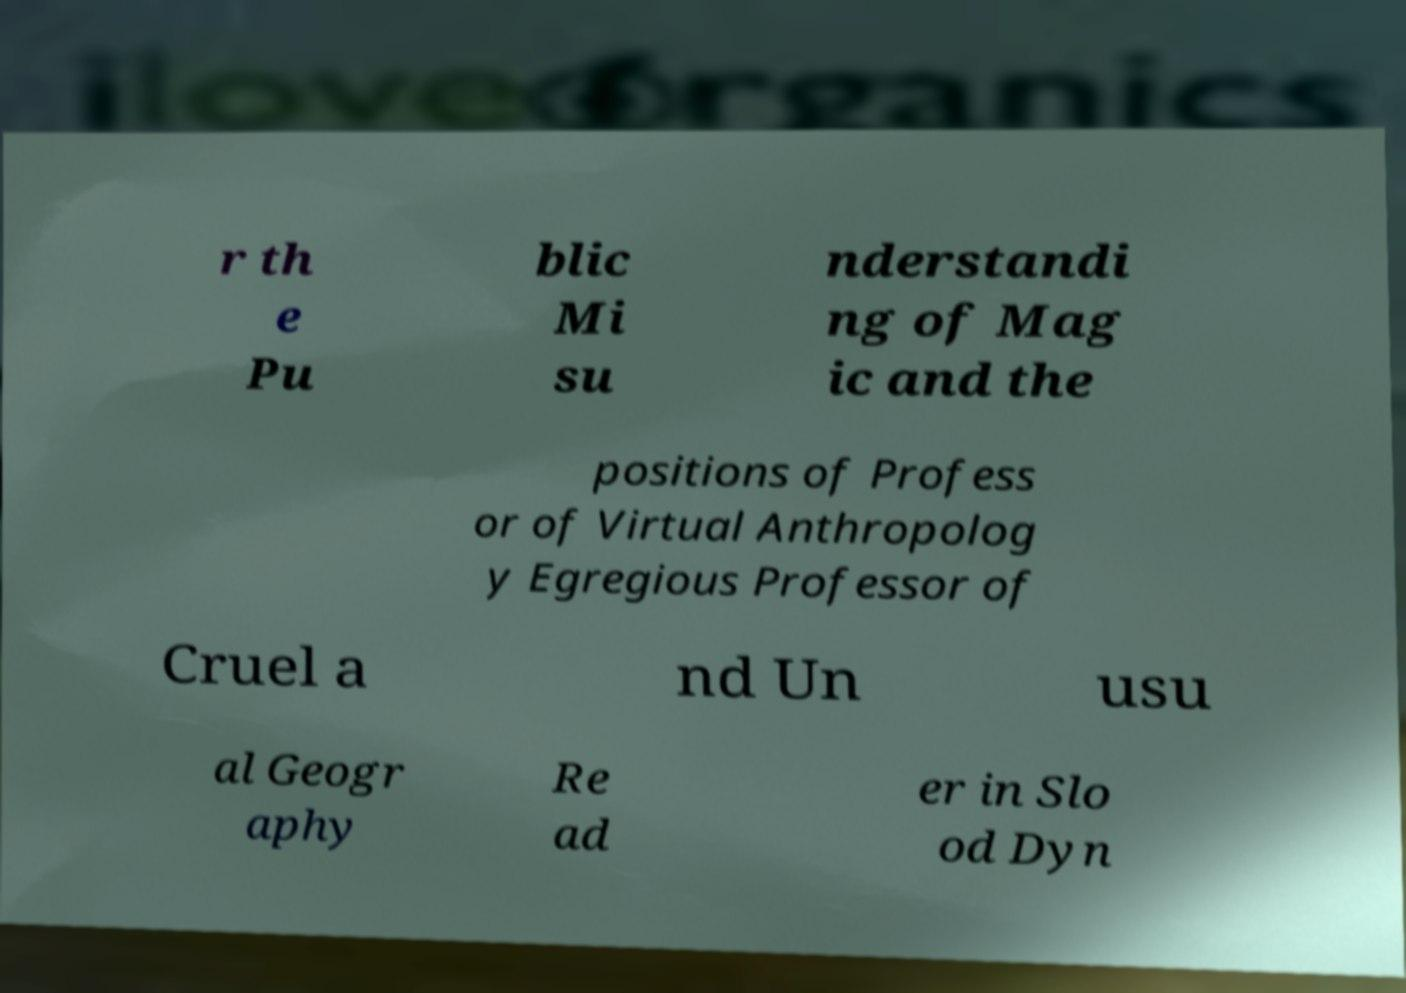Can you accurately transcribe the text from the provided image for me? r th e Pu blic Mi su nderstandi ng of Mag ic and the positions of Profess or of Virtual Anthropolog y Egregious Professor of Cruel a nd Un usu al Geogr aphy Re ad er in Slo od Dyn 